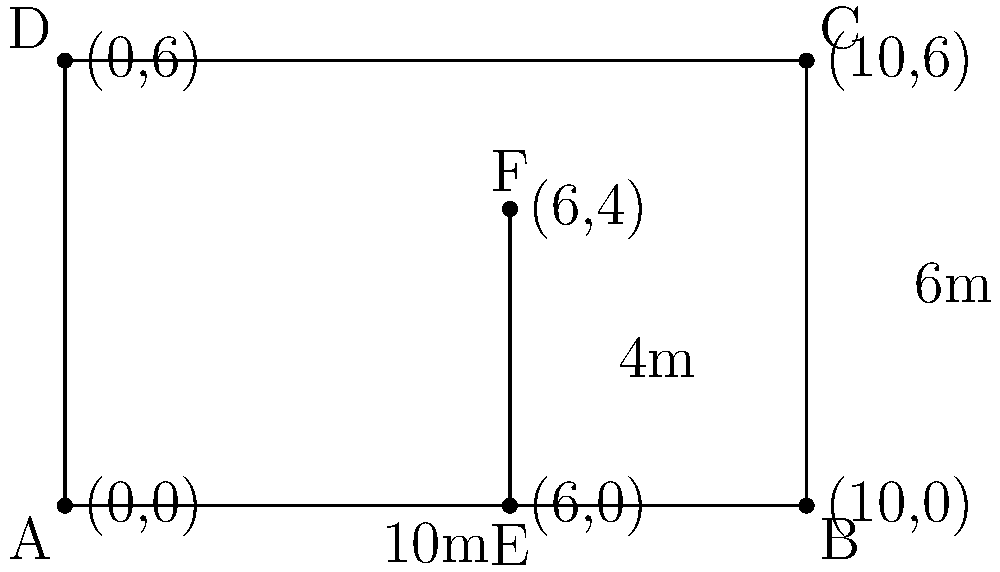As part of a civil service training program, you're tasked with optimizing office space efficiency. The diagram shows a rectangular office space ABCD with dimensions 10m by 6m. A partition EF divides the space into two areas. If the partition is 4m high and located 6m from the left wall, calculate the percentage of the total office volume that the smaller area (AEFD) occupies. Round your answer to the nearest whole percent. Let's approach this step-by-step:

1) First, calculate the total volume of the office:
   $$V_{total} = 10m \times 6m \times 4m = 240m^3$$

2) Now, calculate the volume of the smaller area (AEFD):
   - Base area of AEFD: $$6m \times 6m = 36m^2$$
   - Volume of AEFD: $$36m^2 \times 4m = 144m^3$$

3) Calculate the percentage:
   $$\text{Percentage} = \frac{V_{AEFD}}{V_{total}} \times 100\%$$
   $$= \frac{144m^3}{240m^3} \times 100\% = 0.6 \times 100\% = 60\%$$

4) Rounding to the nearest whole percent: 60%

This calculation demonstrates how geometric principles can be applied to practical office space management, a key aspect of public administration efficiency.
Answer: 60% 